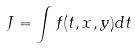<formula> <loc_0><loc_0><loc_500><loc_500>J = \int f ( t , x , y ) d t</formula> 